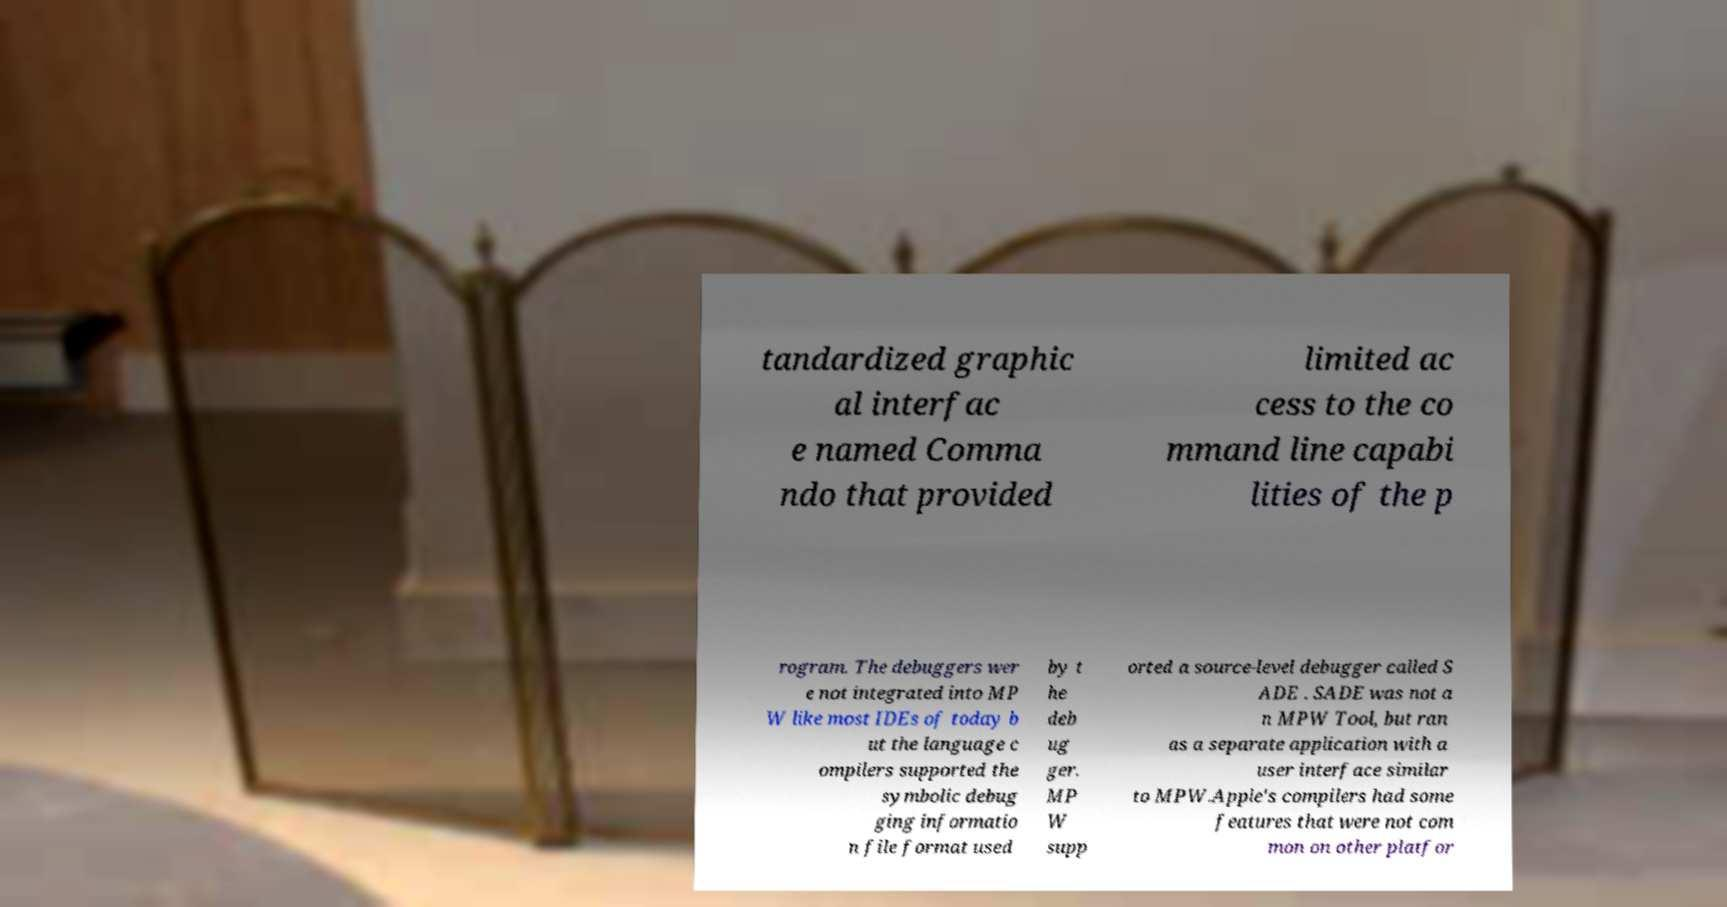I need the written content from this picture converted into text. Can you do that? tandardized graphic al interfac e named Comma ndo that provided limited ac cess to the co mmand line capabi lities of the p rogram. The debuggers wer e not integrated into MP W like most IDEs of today b ut the language c ompilers supported the symbolic debug ging informatio n file format used by t he deb ug ger. MP W supp orted a source-level debugger called S ADE . SADE was not a n MPW Tool, but ran as a separate application with a user interface similar to MPW.Apple's compilers had some features that were not com mon on other platfor 